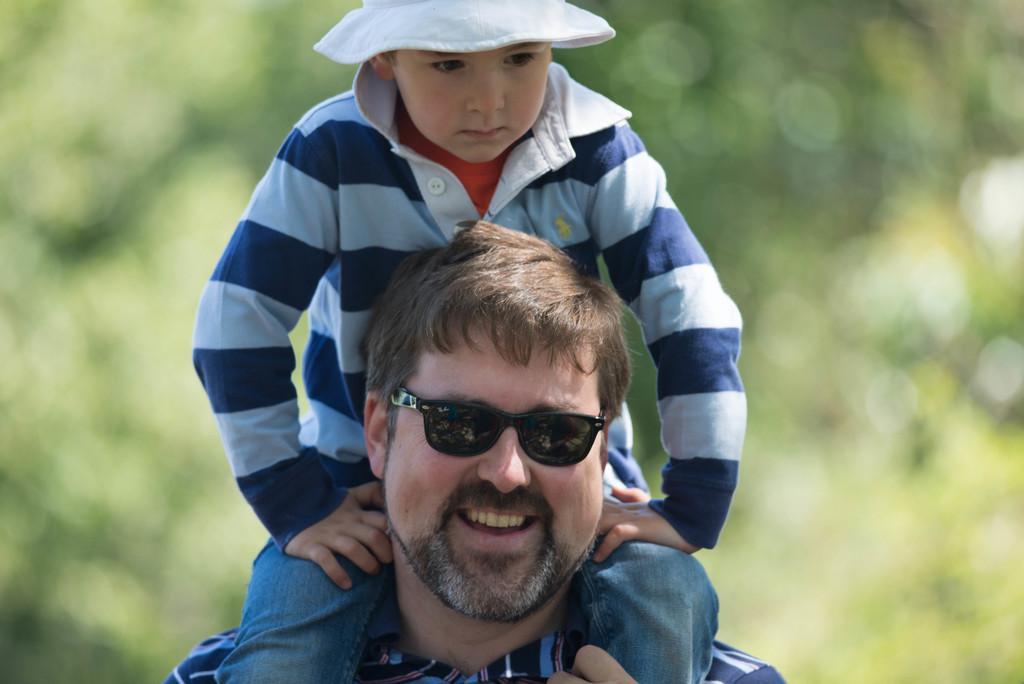In one or two sentences, can you explain what this image depicts? There is a man,he is carrying a boy on his shoulders and he is smiling and he is also wearing black goggles and the background of the man is blur. 